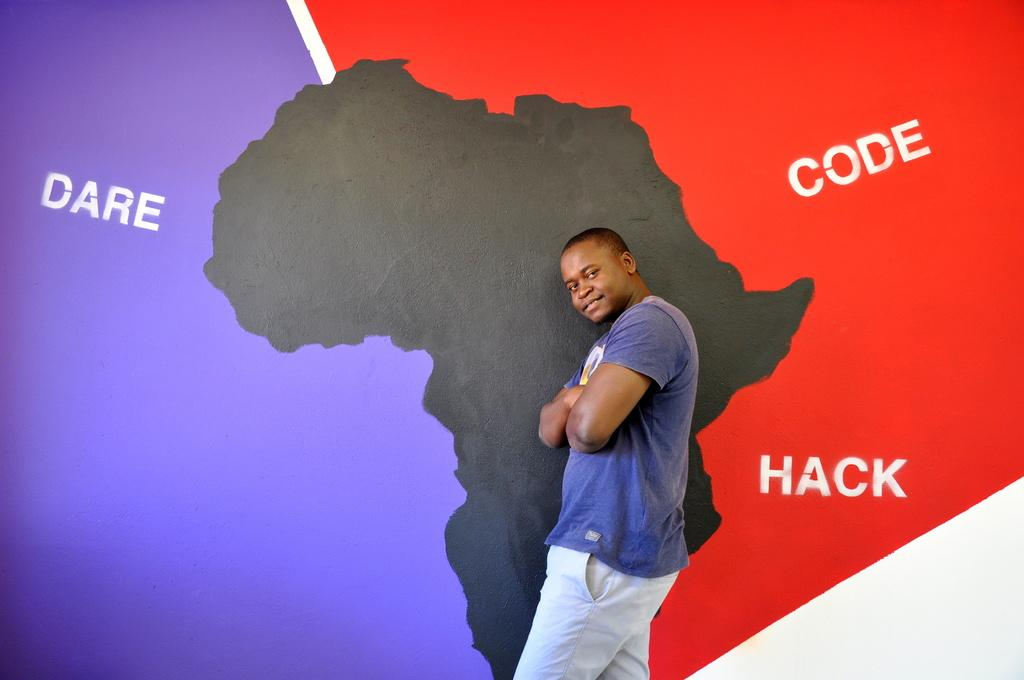<image>
Provide a brief description of the given image. man standing in front of a wall which says Dare Code. 